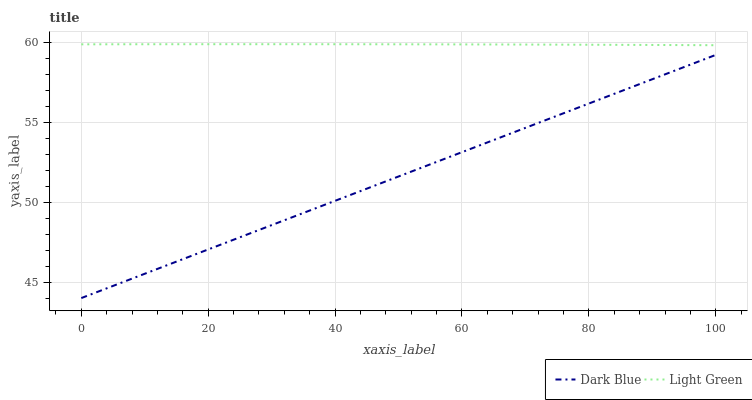Does Light Green have the minimum area under the curve?
Answer yes or no. No. Is Light Green the smoothest?
Answer yes or no. No. Does Light Green have the lowest value?
Answer yes or no. No. Is Dark Blue less than Light Green?
Answer yes or no. Yes. Is Light Green greater than Dark Blue?
Answer yes or no. Yes. Does Dark Blue intersect Light Green?
Answer yes or no. No. 